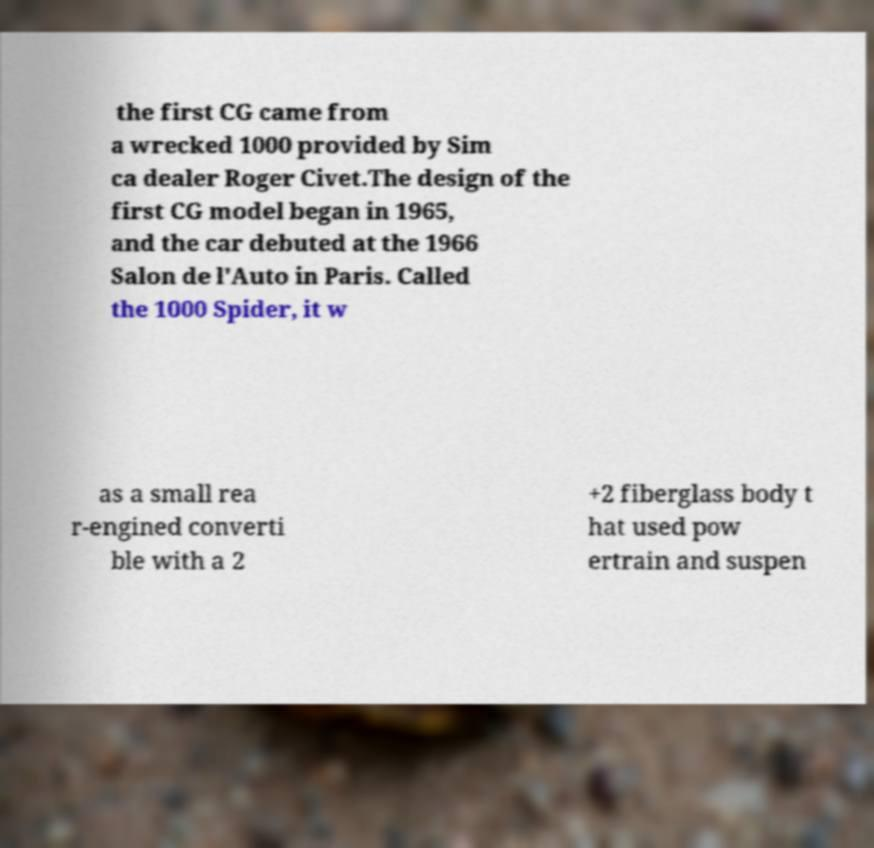Can you accurately transcribe the text from the provided image for me? the first CG came from a wrecked 1000 provided by Sim ca dealer Roger Civet.The design of the first CG model began in 1965, and the car debuted at the 1966 Salon de l'Auto in Paris. Called the 1000 Spider, it w as a small rea r-engined converti ble with a 2 +2 fiberglass body t hat used pow ertrain and suspen 